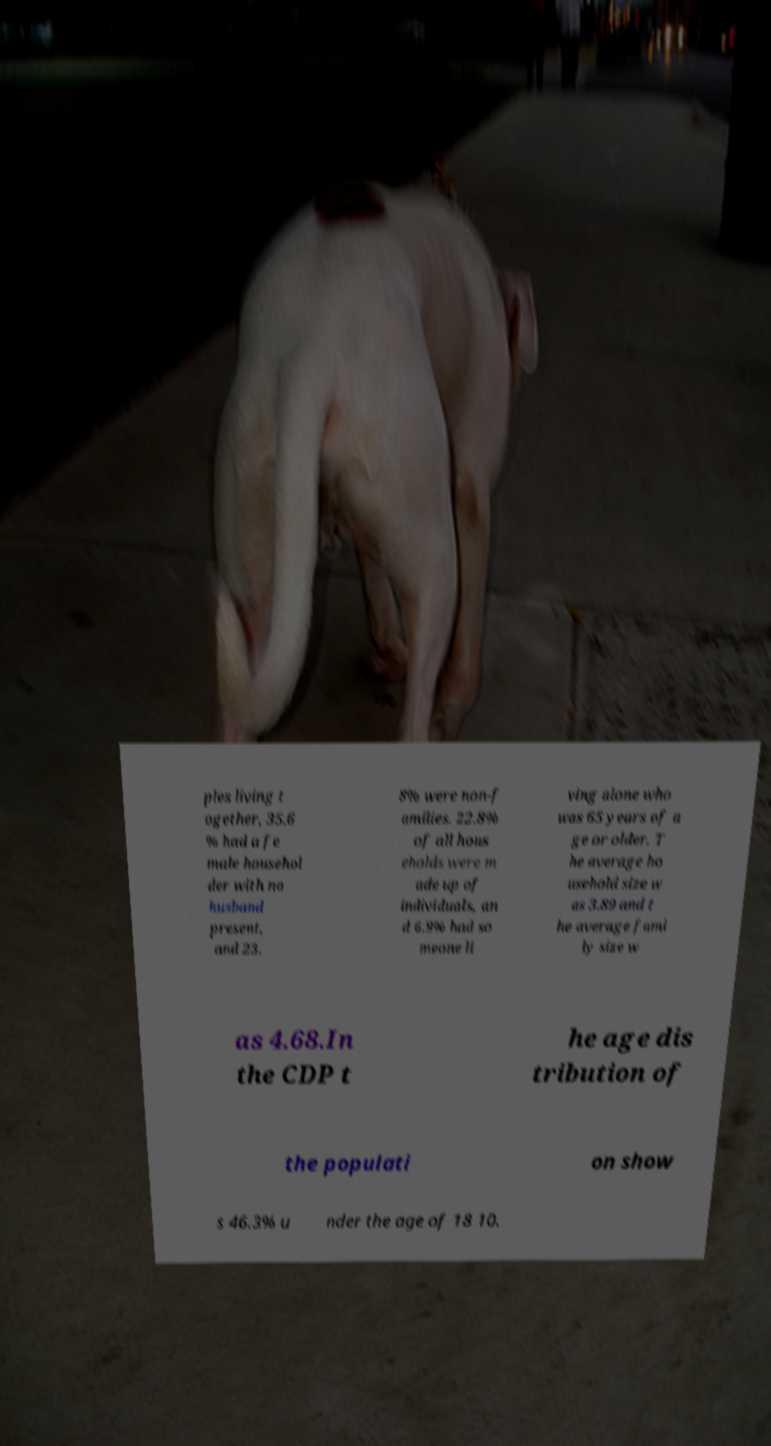I need the written content from this picture converted into text. Can you do that? ples living t ogether, 35.6 % had a fe male househol der with no husband present, and 23. 8% were non-f amilies. 22.8% of all hous eholds were m ade up of individuals, an d 6.9% had so meone li ving alone who was 65 years of a ge or older. T he average ho usehold size w as 3.89 and t he average fami ly size w as 4.68.In the CDP t he age dis tribution of the populati on show s 46.3% u nder the age of 18 10. 